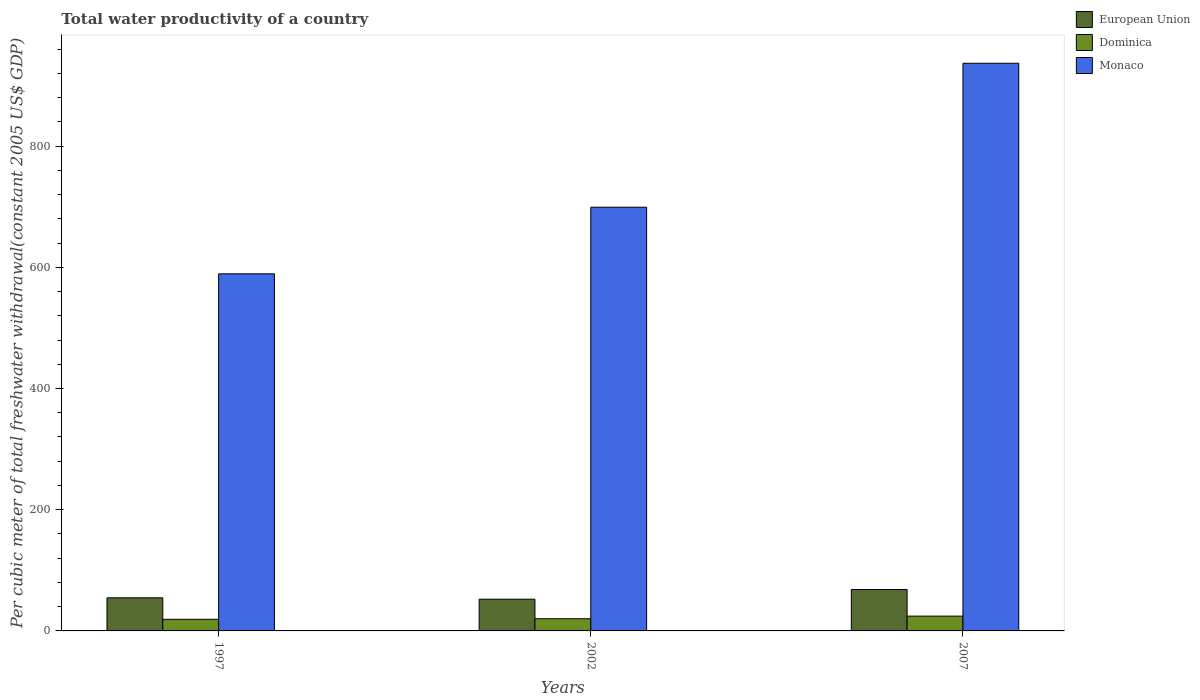How many groups of bars are there?
Make the answer very short. 3. How many bars are there on the 3rd tick from the left?
Make the answer very short. 3. What is the label of the 2nd group of bars from the left?
Make the answer very short. 2002. What is the total water productivity in Dominica in 2007?
Make the answer very short. 24.42. Across all years, what is the maximum total water productivity in European Union?
Offer a very short reply. 68.37. Across all years, what is the minimum total water productivity in Monaco?
Provide a short and direct response. 589.25. In which year was the total water productivity in European Union maximum?
Offer a very short reply. 2007. What is the total total water productivity in Monaco in the graph?
Offer a very short reply. 2225.1. What is the difference between the total water productivity in Monaco in 1997 and that in 2002?
Make the answer very short. -109.9. What is the difference between the total water productivity in Dominica in 1997 and the total water productivity in Monaco in 2002?
Offer a terse response. -679.97. What is the average total water productivity in European Union per year?
Offer a very short reply. 58.45. In the year 2007, what is the difference between the total water productivity in European Union and total water productivity in Monaco?
Your answer should be compact. -868.33. What is the ratio of the total water productivity in European Union in 1997 to that in 2007?
Make the answer very short. 0.8. Is the difference between the total water productivity in European Union in 1997 and 2007 greater than the difference between the total water productivity in Monaco in 1997 and 2007?
Your answer should be very brief. Yes. What is the difference between the highest and the second highest total water productivity in European Union?
Your answer should be very brief. 13.77. What is the difference between the highest and the lowest total water productivity in European Union?
Your answer should be very brief. 16.01. In how many years, is the total water productivity in European Union greater than the average total water productivity in European Union taken over all years?
Your answer should be compact. 1. Is the sum of the total water productivity in European Union in 2002 and 2007 greater than the maximum total water productivity in Dominica across all years?
Give a very brief answer. Yes. What does the 2nd bar from the left in 2002 represents?
Your response must be concise. Dominica. What does the 1st bar from the right in 1997 represents?
Make the answer very short. Monaco. Is it the case that in every year, the sum of the total water productivity in Monaco and total water productivity in European Union is greater than the total water productivity in Dominica?
Offer a terse response. Yes. How many bars are there?
Provide a succinct answer. 9. How many years are there in the graph?
Ensure brevity in your answer.  3. Where does the legend appear in the graph?
Provide a short and direct response. Top right. What is the title of the graph?
Provide a succinct answer. Total water productivity of a country. Does "Belarus" appear as one of the legend labels in the graph?
Offer a very short reply. No. What is the label or title of the Y-axis?
Keep it short and to the point. Per cubic meter of total freshwater withdrawal(constant 2005 US$ GDP). What is the Per cubic meter of total freshwater withdrawal(constant 2005 US$ GDP) in European Union in 1997?
Give a very brief answer. 54.61. What is the Per cubic meter of total freshwater withdrawal(constant 2005 US$ GDP) of Dominica in 1997?
Your response must be concise. 19.18. What is the Per cubic meter of total freshwater withdrawal(constant 2005 US$ GDP) of Monaco in 1997?
Your answer should be very brief. 589.25. What is the Per cubic meter of total freshwater withdrawal(constant 2005 US$ GDP) of European Union in 2002?
Your answer should be very brief. 52.36. What is the Per cubic meter of total freshwater withdrawal(constant 2005 US$ GDP) of Dominica in 2002?
Offer a terse response. 20.08. What is the Per cubic meter of total freshwater withdrawal(constant 2005 US$ GDP) in Monaco in 2002?
Your answer should be very brief. 699.15. What is the Per cubic meter of total freshwater withdrawal(constant 2005 US$ GDP) in European Union in 2007?
Your answer should be compact. 68.37. What is the Per cubic meter of total freshwater withdrawal(constant 2005 US$ GDP) in Dominica in 2007?
Provide a succinct answer. 24.42. What is the Per cubic meter of total freshwater withdrawal(constant 2005 US$ GDP) in Monaco in 2007?
Keep it short and to the point. 936.7. Across all years, what is the maximum Per cubic meter of total freshwater withdrawal(constant 2005 US$ GDP) in European Union?
Keep it short and to the point. 68.37. Across all years, what is the maximum Per cubic meter of total freshwater withdrawal(constant 2005 US$ GDP) of Dominica?
Your answer should be compact. 24.42. Across all years, what is the maximum Per cubic meter of total freshwater withdrawal(constant 2005 US$ GDP) in Monaco?
Make the answer very short. 936.7. Across all years, what is the minimum Per cubic meter of total freshwater withdrawal(constant 2005 US$ GDP) in European Union?
Provide a succinct answer. 52.36. Across all years, what is the minimum Per cubic meter of total freshwater withdrawal(constant 2005 US$ GDP) in Dominica?
Your response must be concise. 19.18. Across all years, what is the minimum Per cubic meter of total freshwater withdrawal(constant 2005 US$ GDP) in Monaco?
Ensure brevity in your answer.  589.25. What is the total Per cubic meter of total freshwater withdrawal(constant 2005 US$ GDP) of European Union in the graph?
Provide a succinct answer. 175.34. What is the total Per cubic meter of total freshwater withdrawal(constant 2005 US$ GDP) in Dominica in the graph?
Keep it short and to the point. 63.69. What is the total Per cubic meter of total freshwater withdrawal(constant 2005 US$ GDP) of Monaco in the graph?
Provide a short and direct response. 2225.1. What is the difference between the Per cubic meter of total freshwater withdrawal(constant 2005 US$ GDP) in European Union in 1997 and that in 2002?
Ensure brevity in your answer.  2.25. What is the difference between the Per cubic meter of total freshwater withdrawal(constant 2005 US$ GDP) in Dominica in 1997 and that in 2002?
Your answer should be compact. -0.91. What is the difference between the Per cubic meter of total freshwater withdrawal(constant 2005 US$ GDP) of Monaco in 1997 and that in 2002?
Your answer should be compact. -109.9. What is the difference between the Per cubic meter of total freshwater withdrawal(constant 2005 US$ GDP) of European Union in 1997 and that in 2007?
Keep it short and to the point. -13.77. What is the difference between the Per cubic meter of total freshwater withdrawal(constant 2005 US$ GDP) of Dominica in 1997 and that in 2007?
Ensure brevity in your answer.  -5.25. What is the difference between the Per cubic meter of total freshwater withdrawal(constant 2005 US$ GDP) in Monaco in 1997 and that in 2007?
Your answer should be very brief. -347.45. What is the difference between the Per cubic meter of total freshwater withdrawal(constant 2005 US$ GDP) in European Union in 2002 and that in 2007?
Offer a very short reply. -16.01. What is the difference between the Per cubic meter of total freshwater withdrawal(constant 2005 US$ GDP) of Dominica in 2002 and that in 2007?
Give a very brief answer. -4.34. What is the difference between the Per cubic meter of total freshwater withdrawal(constant 2005 US$ GDP) in Monaco in 2002 and that in 2007?
Give a very brief answer. -237.55. What is the difference between the Per cubic meter of total freshwater withdrawal(constant 2005 US$ GDP) of European Union in 1997 and the Per cubic meter of total freshwater withdrawal(constant 2005 US$ GDP) of Dominica in 2002?
Ensure brevity in your answer.  34.52. What is the difference between the Per cubic meter of total freshwater withdrawal(constant 2005 US$ GDP) in European Union in 1997 and the Per cubic meter of total freshwater withdrawal(constant 2005 US$ GDP) in Monaco in 2002?
Offer a terse response. -644.55. What is the difference between the Per cubic meter of total freshwater withdrawal(constant 2005 US$ GDP) in Dominica in 1997 and the Per cubic meter of total freshwater withdrawal(constant 2005 US$ GDP) in Monaco in 2002?
Offer a terse response. -679.97. What is the difference between the Per cubic meter of total freshwater withdrawal(constant 2005 US$ GDP) in European Union in 1997 and the Per cubic meter of total freshwater withdrawal(constant 2005 US$ GDP) in Dominica in 2007?
Your answer should be very brief. 30.18. What is the difference between the Per cubic meter of total freshwater withdrawal(constant 2005 US$ GDP) of European Union in 1997 and the Per cubic meter of total freshwater withdrawal(constant 2005 US$ GDP) of Monaco in 2007?
Offer a very short reply. -882.09. What is the difference between the Per cubic meter of total freshwater withdrawal(constant 2005 US$ GDP) of Dominica in 1997 and the Per cubic meter of total freshwater withdrawal(constant 2005 US$ GDP) of Monaco in 2007?
Keep it short and to the point. -917.52. What is the difference between the Per cubic meter of total freshwater withdrawal(constant 2005 US$ GDP) of European Union in 2002 and the Per cubic meter of total freshwater withdrawal(constant 2005 US$ GDP) of Dominica in 2007?
Make the answer very short. 27.94. What is the difference between the Per cubic meter of total freshwater withdrawal(constant 2005 US$ GDP) of European Union in 2002 and the Per cubic meter of total freshwater withdrawal(constant 2005 US$ GDP) of Monaco in 2007?
Your answer should be very brief. -884.34. What is the difference between the Per cubic meter of total freshwater withdrawal(constant 2005 US$ GDP) of Dominica in 2002 and the Per cubic meter of total freshwater withdrawal(constant 2005 US$ GDP) of Monaco in 2007?
Provide a short and direct response. -916.61. What is the average Per cubic meter of total freshwater withdrawal(constant 2005 US$ GDP) in European Union per year?
Your answer should be very brief. 58.45. What is the average Per cubic meter of total freshwater withdrawal(constant 2005 US$ GDP) in Dominica per year?
Your response must be concise. 21.23. What is the average Per cubic meter of total freshwater withdrawal(constant 2005 US$ GDP) in Monaco per year?
Offer a very short reply. 741.7. In the year 1997, what is the difference between the Per cubic meter of total freshwater withdrawal(constant 2005 US$ GDP) in European Union and Per cubic meter of total freshwater withdrawal(constant 2005 US$ GDP) in Dominica?
Ensure brevity in your answer.  35.43. In the year 1997, what is the difference between the Per cubic meter of total freshwater withdrawal(constant 2005 US$ GDP) in European Union and Per cubic meter of total freshwater withdrawal(constant 2005 US$ GDP) in Monaco?
Your response must be concise. -534.64. In the year 1997, what is the difference between the Per cubic meter of total freshwater withdrawal(constant 2005 US$ GDP) of Dominica and Per cubic meter of total freshwater withdrawal(constant 2005 US$ GDP) of Monaco?
Offer a terse response. -570.07. In the year 2002, what is the difference between the Per cubic meter of total freshwater withdrawal(constant 2005 US$ GDP) in European Union and Per cubic meter of total freshwater withdrawal(constant 2005 US$ GDP) in Dominica?
Your answer should be very brief. 32.28. In the year 2002, what is the difference between the Per cubic meter of total freshwater withdrawal(constant 2005 US$ GDP) of European Union and Per cubic meter of total freshwater withdrawal(constant 2005 US$ GDP) of Monaco?
Keep it short and to the point. -646.79. In the year 2002, what is the difference between the Per cubic meter of total freshwater withdrawal(constant 2005 US$ GDP) of Dominica and Per cubic meter of total freshwater withdrawal(constant 2005 US$ GDP) of Monaco?
Ensure brevity in your answer.  -679.07. In the year 2007, what is the difference between the Per cubic meter of total freshwater withdrawal(constant 2005 US$ GDP) of European Union and Per cubic meter of total freshwater withdrawal(constant 2005 US$ GDP) of Dominica?
Make the answer very short. 43.95. In the year 2007, what is the difference between the Per cubic meter of total freshwater withdrawal(constant 2005 US$ GDP) of European Union and Per cubic meter of total freshwater withdrawal(constant 2005 US$ GDP) of Monaco?
Your response must be concise. -868.33. In the year 2007, what is the difference between the Per cubic meter of total freshwater withdrawal(constant 2005 US$ GDP) in Dominica and Per cubic meter of total freshwater withdrawal(constant 2005 US$ GDP) in Monaco?
Offer a very short reply. -912.27. What is the ratio of the Per cubic meter of total freshwater withdrawal(constant 2005 US$ GDP) of European Union in 1997 to that in 2002?
Ensure brevity in your answer.  1.04. What is the ratio of the Per cubic meter of total freshwater withdrawal(constant 2005 US$ GDP) of Dominica in 1997 to that in 2002?
Ensure brevity in your answer.  0.95. What is the ratio of the Per cubic meter of total freshwater withdrawal(constant 2005 US$ GDP) of Monaco in 1997 to that in 2002?
Offer a terse response. 0.84. What is the ratio of the Per cubic meter of total freshwater withdrawal(constant 2005 US$ GDP) of European Union in 1997 to that in 2007?
Provide a short and direct response. 0.8. What is the ratio of the Per cubic meter of total freshwater withdrawal(constant 2005 US$ GDP) in Dominica in 1997 to that in 2007?
Provide a short and direct response. 0.79. What is the ratio of the Per cubic meter of total freshwater withdrawal(constant 2005 US$ GDP) of Monaco in 1997 to that in 2007?
Provide a short and direct response. 0.63. What is the ratio of the Per cubic meter of total freshwater withdrawal(constant 2005 US$ GDP) in European Union in 2002 to that in 2007?
Provide a succinct answer. 0.77. What is the ratio of the Per cubic meter of total freshwater withdrawal(constant 2005 US$ GDP) of Dominica in 2002 to that in 2007?
Give a very brief answer. 0.82. What is the ratio of the Per cubic meter of total freshwater withdrawal(constant 2005 US$ GDP) in Monaco in 2002 to that in 2007?
Offer a very short reply. 0.75. What is the difference between the highest and the second highest Per cubic meter of total freshwater withdrawal(constant 2005 US$ GDP) of European Union?
Your answer should be very brief. 13.77. What is the difference between the highest and the second highest Per cubic meter of total freshwater withdrawal(constant 2005 US$ GDP) in Dominica?
Provide a succinct answer. 4.34. What is the difference between the highest and the second highest Per cubic meter of total freshwater withdrawal(constant 2005 US$ GDP) of Monaco?
Make the answer very short. 237.55. What is the difference between the highest and the lowest Per cubic meter of total freshwater withdrawal(constant 2005 US$ GDP) of European Union?
Your answer should be very brief. 16.01. What is the difference between the highest and the lowest Per cubic meter of total freshwater withdrawal(constant 2005 US$ GDP) in Dominica?
Provide a short and direct response. 5.25. What is the difference between the highest and the lowest Per cubic meter of total freshwater withdrawal(constant 2005 US$ GDP) in Monaco?
Keep it short and to the point. 347.45. 